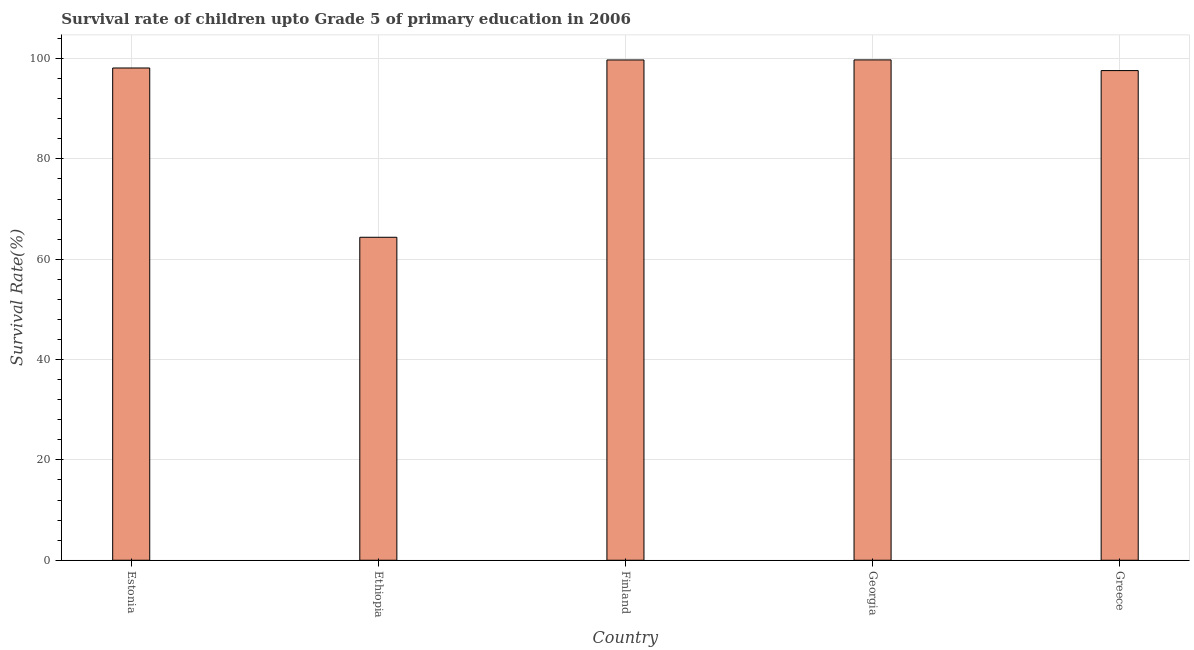What is the title of the graph?
Make the answer very short. Survival rate of children upto Grade 5 of primary education in 2006 . What is the label or title of the Y-axis?
Your answer should be very brief. Survival Rate(%). What is the survival rate in Finland?
Offer a terse response. 99.72. Across all countries, what is the maximum survival rate?
Ensure brevity in your answer.  99.73. Across all countries, what is the minimum survival rate?
Provide a short and direct response. 64.38. In which country was the survival rate maximum?
Offer a very short reply. Georgia. In which country was the survival rate minimum?
Provide a short and direct response. Ethiopia. What is the sum of the survival rate?
Give a very brief answer. 459.55. What is the difference between the survival rate in Ethiopia and Finland?
Your answer should be very brief. -35.34. What is the average survival rate per country?
Offer a very short reply. 91.91. What is the median survival rate?
Give a very brief answer. 98.12. What is the ratio of the survival rate in Estonia to that in Ethiopia?
Keep it short and to the point. 1.52. Is the survival rate in Estonia less than that in Finland?
Offer a terse response. Yes. What is the difference between the highest and the second highest survival rate?
Provide a succinct answer. 0.01. What is the difference between the highest and the lowest survival rate?
Your answer should be very brief. 35.36. In how many countries, is the survival rate greater than the average survival rate taken over all countries?
Provide a short and direct response. 4. How many bars are there?
Ensure brevity in your answer.  5. How many countries are there in the graph?
Make the answer very short. 5. What is the difference between two consecutive major ticks on the Y-axis?
Your answer should be compact. 20. What is the Survival Rate(%) of Estonia?
Make the answer very short. 98.12. What is the Survival Rate(%) in Ethiopia?
Your answer should be very brief. 64.38. What is the Survival Rate(%) in Finland?
Keep it short and to the point. 99.72. What is the Survival Rate(%) in Georgia?
Provide a short and direct response. 99.73. What is the Survival Rate(%) in Greece?
Provide a succinct answer. 97.6. What is the difference between the Survival Rate(%) in Estonia and Ethiopia?
Give a very brief answer. 33.74. What is the difference between the Survival Rate(%) in Estonia and Finland?
Your response must be concise. -1.6. What is the difference between the Survival Rate(%) in Estonia and Georgia?
Ensure brevity in your answer.  -1.61. What is the difference between the Survival Rate(%) in Estonia and Greece?
Make the answer very short. 0.52. What is the difference between the Survival Rate(%) in Ethiopia and Finland?
Provide a succinct answer. -35.34. What is the difference between the Survival Rate(%) in Ethiopia and Georgia?
Offer a very short reply. -35.36. What is the difference between the Survival Rate(%) in Ethiopia and Greece?
Ensure brevity in your answer.  -33.22. What is the difference between the Survival Rate(%) in Finland and Georgia?
Make the answer very short. -0.02. What is the difference between the Survival Rate(%) in Finland and Greece?
Provide a short and direct response. 2.12. What is the difference between the Survival Rate(%) in Georgia and Greece?
Your response must be concise. 2.13. What is the ratio of the Survival Rate(%) in Estonia to that in Ethiopia?
Your answer should be very brief. 1.52. What is the ratio of the Survival Rate(%) in Estonia to that in Finland?
Your response must be concise. 0.98. What is the ratio of the Survival Rate(%) in Estonia to that in Georgia?
Ensure brevity in your answer.  0.98. What is the ratio of the Survival Rate(%) in Estonia to that in Greece?
Give a very brief answer. 1. What is the ratio of the Survival Rate(%) in Ethiopia to that in Finland?
Make the answer very short. 0.65. What is the ratio of the Survival Rate(%) in Ethiopia to that in Georgia?
Ensure brevity in your answer.  0.65. What is the ratio of the Survival Rate(%) in Ethiopia to that in Greece?
Your answer should be very brief. 0.66. What is the ratio of the Survival Rate(%) in Finland to that in Greece?
Make the answer very short. 1.02. 